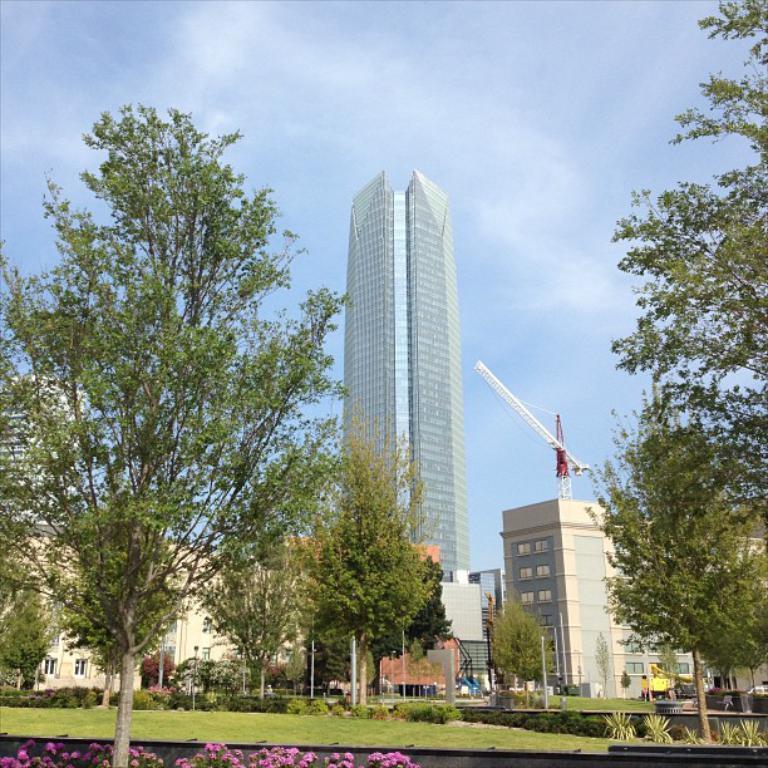Please provide a concise description of this image. In the image I can see a place where we have some buildings, houses and some trees and plants which has some flowers. 